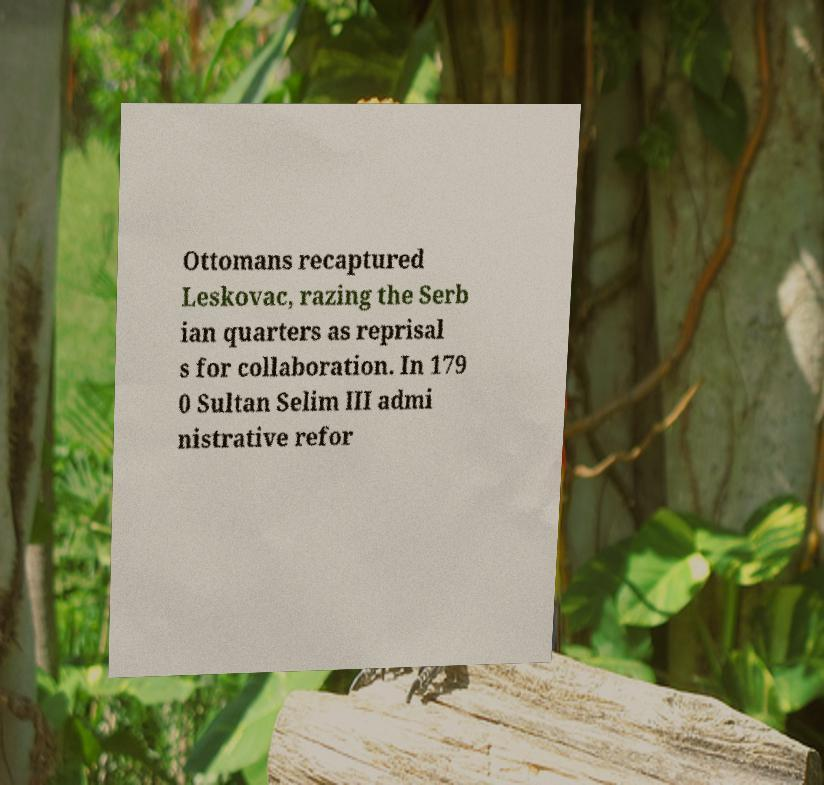Please identify and transcribe the text found in this image. Ottomans recaptured Leskovac, razing the Serb ian quarters as reprisal s for collaboration. In 179 0 Sultan Selim III admi nistrative refor 